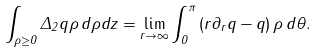<formula> <loc_0><loc_0><loc_500><loc_500>\int _ { \rho \geq 0 } \Delta _ { 2 } q \rho \, d \rho d z = \lim _ { r \to \infty } \int _ { 0 } ^ { \pi } \left ( r \partial _ { r } q - q \right ) \rho \, d \theta .</formula> 